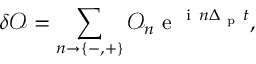<formula> <loc_0><loc_0><loc_500><loc_500>\delta \mathcal { O } = \sum _ { n \rightarrow { \{ - , + \} } } \mathcal { O } _ { n } e ^ { i n \Delta _ { p } t } ,</formula> 